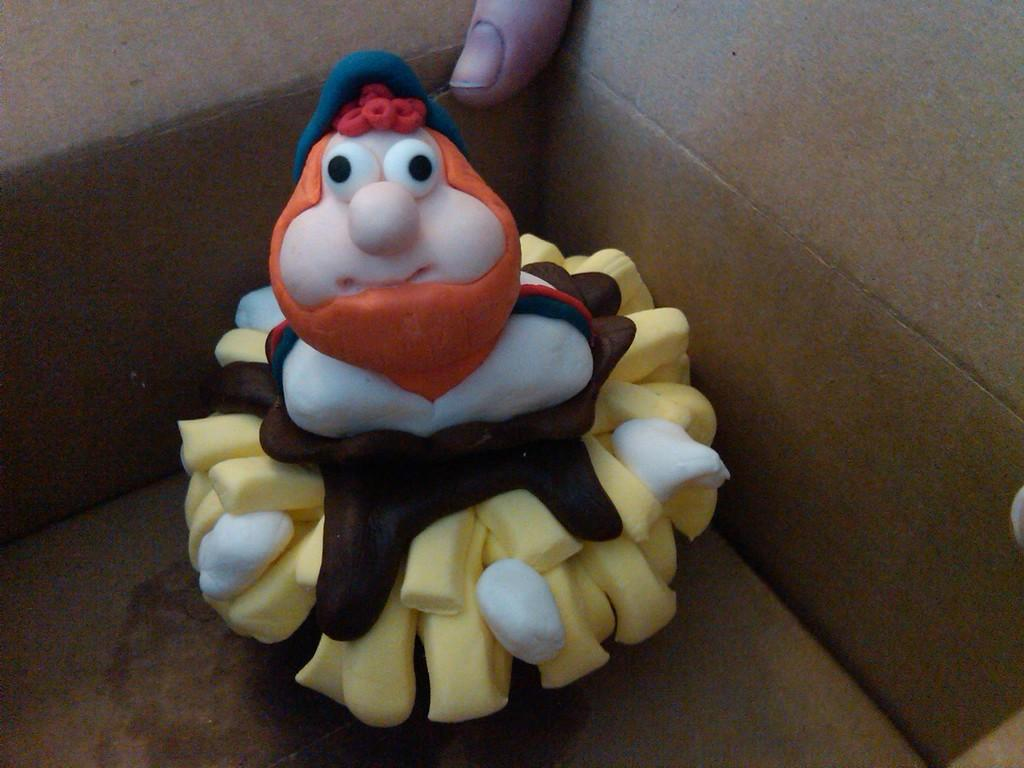What is the focus of the image? The image is zoomed in on a toy of a person in the foreground. What is the toy's location? The toy appears to be placed in a box. Can you see any part of a person in the image? Yes, there is a thumb of a person visible in the background. What type of beginner's training is depicted in the image? There is no depiction of any training or skill development in the image; it features a toy of a person placed in a box. Can you tell me how many bombs are present in the image? There are no bombs present in the image; it only shows a toy of a person in a box and a thumb in the background. 